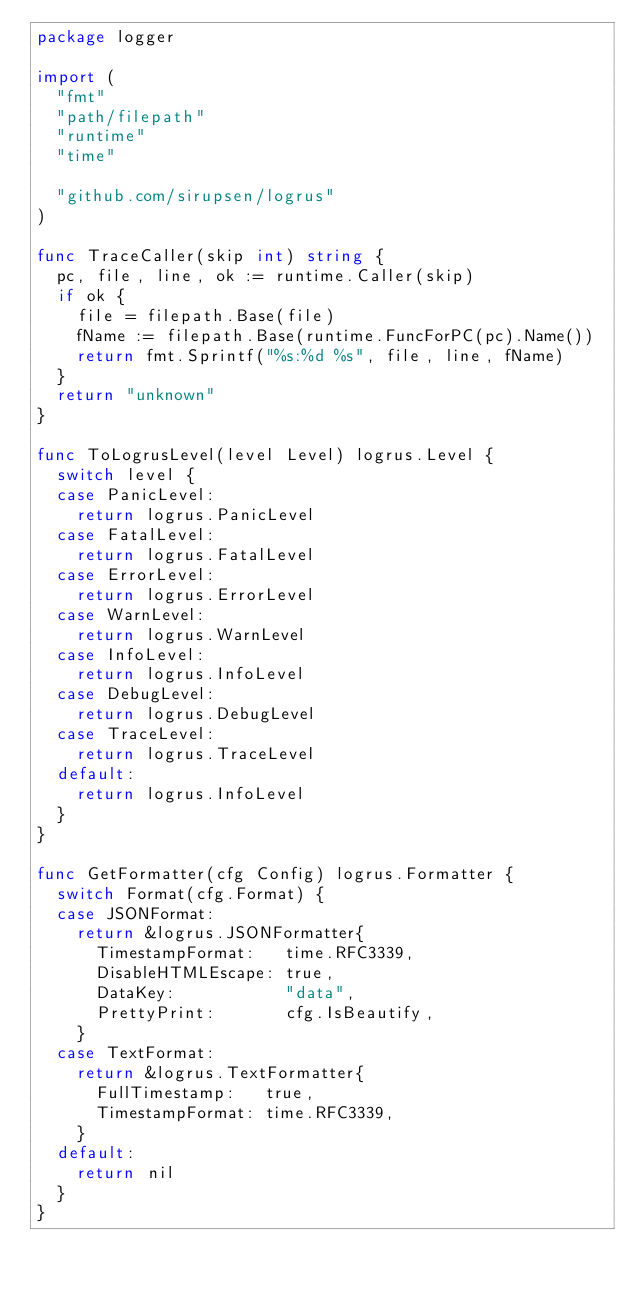<code> <loc_0><loc_0><loc_500><loc_500><_Go_>package logger

import (
	"fmt"
	"path/filepath"
	"runtime"
	"time"

	"github.com/sirupsen/logrus"
)

func TraceCaller(skip int) string {
	pc, file, line, ok := runtime.Caller(skip)
	if ok {
		file = filepath.Base(file)
		fName := filepath.Base(runtime.FuncForPC(pc).Name())
		return fmt.Sprintf("%s:%d %s", file, line, fName)
	}
	return "unknown"
}

func ToLogrusLevel(level Level) logrus.Level {
	switch level {
	case PanicLevel:
		return logrus.PanicLevel
	case FatalLevel:
		return logrus.FatalLevel
	case ErrorLevel:
		return logrus.ErrorLevel
	case WarnLevel:
		return logrus.WarnLevel
	case InfoLevel:
		return logrus.InfoLevel
	case DebugLevel:
		return logrus.DebugLevel
	case TraceLevel:
		return logrus.TraceLevel
	default:
		return logrus.InfoLevel
	}
}

func GetFormatter(cfg Config) logrus.Formatter {
	switch Format(cfg.Format) {
	case JSONFormat:
		return &logrus.JSONFormatter{
			TimestampFormat:   time.RFC3339,
			DisableHTMLEscape: true,
			DataKey:           "data",
			PrettyPrint:       cfg.IsBeautify,
		}
	case TextFormat:
		return &logrus.TextFormatter{
			FullTimestamp:   true,
			TimestampFormat: time.RFC3339,
		}
	default:
		return nil
	}
}
</code> 